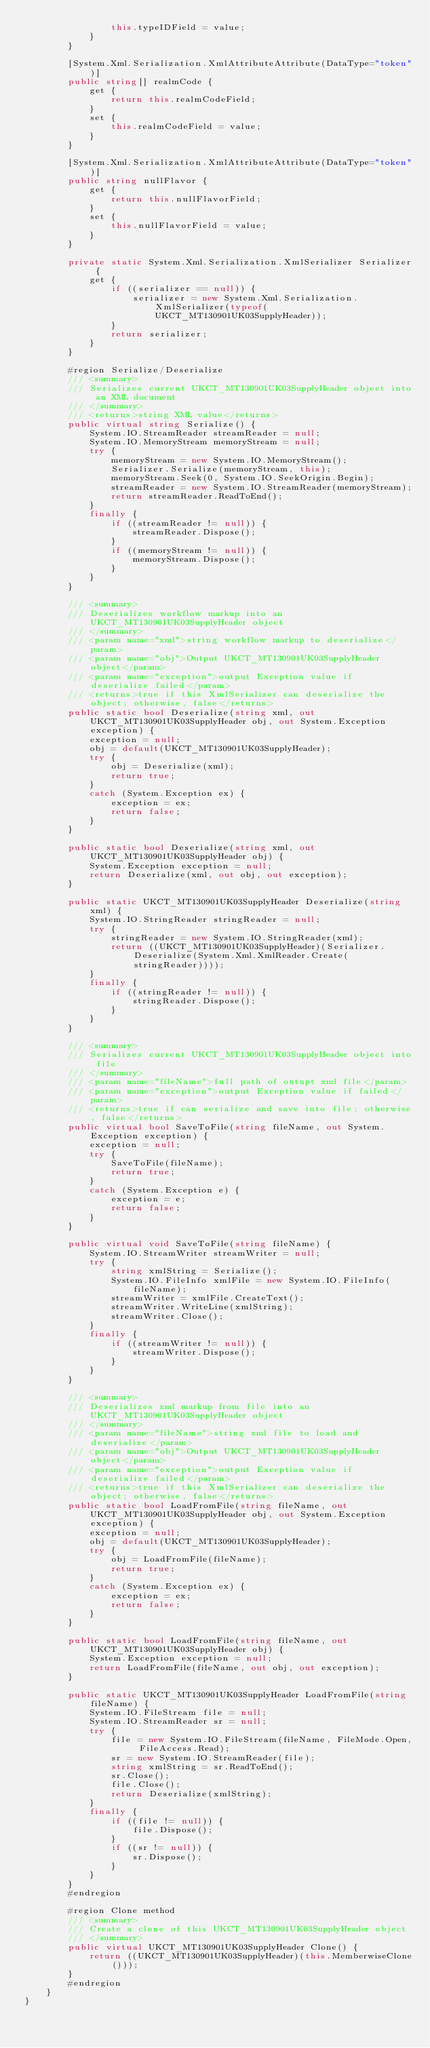Convert code to text. <code><loc_0><loc_0><loc_500><loc_500><_C#_>                this.typeIDField = value;
            }
        }
        
        [System.Xml.Serialization.XmlAttributeAttribute(DataType="token")]
        public string[] realmCode {
            get {
                return this.realmCodeField;
            }
            set {
                this.realmCodeField = value;
            }
        }
        
        [System.Xml.Serialization.XmlAttributeAttribute(DataType="token")]
        public string nullFlavor {
            get {
                return this.nullFlavorField;
            }
            set {
                this.nullFlavorField = value;
            }
        }
        
        private static System.Xml.Serialization.XmlSerializer Serializer {
            get {
                if ((serializer == null)) {
                    serializer = new System.Xml.Serialization.XmlSerializer(typeof(UKCT_MT130901UK03SupplyHeader));
                }
                return serializer;
            }
        }
        
        #region Serialize/Deserialize
        /// <summary>
        /// Serializes current UKCT_MT130901UK03SupplyHeader object into an XML document
        /// </summary>
        /// <returns>string XML value</returns>
        public virtual string Serialize() {
            System.IO.StreamReader streamReader = null;
            System.IO.MemoryStream memoryStream = null;
            try {
                memoryStream = new System.IO.MemoryStream();
                Serializer.Serialize(memoryStream, this);
                memoryStream.Seek(0, System.IO.SeekOrigin.Begin);
                streamReader = new System.IO.StreamReader(memoryStream);
                return streamReader.ReadToEnd();
            }
            finally {
                if ((streamReader != null)) {
                    streamReader.Dispose();
                }
                if ((memoryStream != null)) {
                    memoryStream.Dispose();
                }
            }
        }
        
        /// <summary>
        /// Deserializes workflow markup into an UKCT_MT130901UK03SupplyHeader object
        /// </summary>
        /// <param name="xml">string workflow markup to deserialize</param>
        /// <param name="obj">Output UKCT_MT130901UK03SupplyHeader object</param>
        /// <param name="exception">output Exception value if deserialize failed</param>
        /// <returns>true if this XmlSerializer can deserialize the object; otherwise, false</returns>
        public static bool Deserialize(string xml, out UKCT_MT130901UK03SupplyHeader obj, out System.Exception exception) {
            exception = null;
            obj = default(UKCT_MT130901UK03SupplyHeader);
            try {
                obj = Deserialize(xml);
                return true;
            }
            catch (System.Exception ex) {
                exception = ex;
                return false;
            }
        }
        
        public static bool Deserialize(string xml, out UKCT_MT130901UK03SupplyHeader obj) {
            System.Exception exception = null;
            return Deserialize(xml, out obj, out exception);
        }
        
        public static UKCT_MT130901UK03SupplyHeader Deserialize(string xml) {
            System.IO.StringReader stringReader = null;
            try {
                stringReader = new System.IO.StringReader(xml);
                return ((UKCT_MT130901UK03SupplyHeader)(Serializer.Deserialize(System.Xml.XmlReader.Create(stringReader))));
            }
            finally {
                if ((stringReader != null)) {
                    stringReader.Dispose();
                }
            }
        }
        
        /// <summary>
        /// Serializes current UKCT_MT130901UK03SupplyHeader object into file
        /// </summary>
        /// <param name="fileName">full path of outupt xml file</param>
        /// <param name="exception">output Exception value if failed</param>
        /// <returns>true if can serialize and save into file; otherwise, false</returns>
        public virtual bool SaveToFile(string fileName, out System.Exception exception) {
            exception = null;
            try {
                SaveToFile(fileName);
                return true;
            }
            catch (System.Exception e) {
                exception = e;
                return false;
            }
        }
        
        public virtual void SaveToFile(string fileName) {
            System.IO.StreamWriter streamWriter = null;
            try {
                string xmlString = Serialize();
                System.IO.FileInfo xmlFile = new System.IO.FileInfo(fileName);
                streamWriter = xmlFile.CreateText();
                streamWriter.WriteLine(xmlString);
                streamWriter.Close();
            }
            finally {
                if ((streamWriter != null)) {
                    streamWriter.Dispose();
                }
            }
        }
        
        /// <summary>
        /// Deserializes xml markup from file into an UKCT_MT130901UK03SupplyHeader object
        /// </summary>
        /// <param name="fileName">string xml file to load and deserialize</param>
        /// <param name="obj">Output UKCT_MT130901UK03SupplyHeader object</param>
        /// <param name="exception">output Exception value if deserialize failed</param>
        /// <returns>true if this XmlSerializer can deserialize the object; otherwise, false</returns>
        public static bool LoadFromFile(string fileName, out UKCT_MT130901UK03SupplyHeader obj, out System.Exception exception) {
            exception = null;
            obj = default(UKCT_MT130901UK03SupplyHeader);
            try {
                obj = LoadFromFile(fileName);
                return true;
            }
            catch (System.Exception ex) {
                exception = ex;
                return false;
            }
        }
        
        public static bool LoadFromFile(string fileName, out UKCT_MT130901UK03SupplyHeader obj) {
            System.Exception exception = null;
            return LoadFromFile(fileName, out obj, out exception);
        }
        
        public static UKCT_MT130901UK03SupplyHeader LoadFromFile(string fileName) {
            System.IO.FileStream file = null;
            System.IO.StreamReader sr = null;
            try {
                file = new System.IO.FileStream(fileName, FileMode.Open, FileAccess.Read);
                sr = new System.IO.StreamReader(file);
                string xmlString = sr.ReadToEnd();
                sr.Close();
                file.Close();
                return Deserialize(xmlString);
            }
            finally {
                if ((file != null)) {
                    file.Dispose();
                }
                if ((sr != null)) {
                    sr.Dispose();
                }
            }
        }
        #endregion
        
        #region Clone method
        /// <summary>
        /// Create a clone of this UKCT_MT130901UK03SupplyHeader object
        /// </summary>
        public virtual UKCT_MT130901UK03SupplyHeader Clone() {
            return ((UKCT_MT130901UK03SupplyHeader)(this.MemberwiseClone()));
        }
        #endregion
    }
}
</code> 